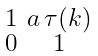<formula> <loc_0><loc_0><loc_500><loc_500>\begin{smallmatrix} 1 & a \, \tau ( k ) \\ 0 & 1 \end{smallmatrix}</formula> 